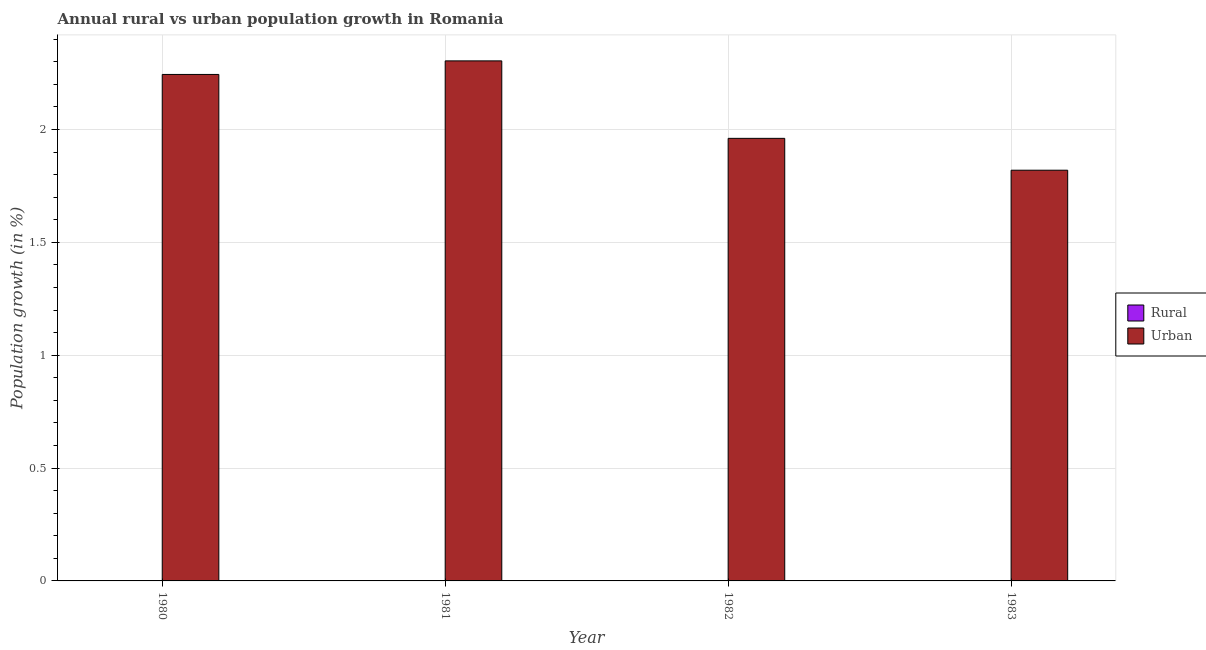Are the number of bars per tick equal to the number of legend labels?
Give a very brief answer. No. Are the number of bars on each tick of the X-axis equal?
Give a very brief answer. Yes. How many bars are there on the 3rd tick from the right?
Your answer should be compact. 1. In how many cases, is the number of bars for a given year not equal to the number of legend labels?
Keep it short and to the point. 4. What is the urban population growth in 1983?
Provide a succinct answer. 1.82. Across all years, what is the maximum urban population growth?
Make the answer very short. 2.3. Across all years, what is the minimum urban population growth?
Your answer should be very brief. 1.82. In which year was the urban population growth maximum?
Provide a short and direct response. 1981. What is the difference between the urban population growth in 1980 and that in 1982?
Your answer should be compact. 0.28. What is the difference between the rural population growth in 1980 and the urban population growth in 1983?
Ensure brevity in your answer.  0. What is the average urban population growth per year?
Your answer should be very brief. 2.08. In the year 1983, what is the difference between the urban population growth and rural population growth?
Your response must be concise. 0. In how many years, is the rural population growth greater than 2 %?
Give a very brief answer. 0. What is the ratio of the urban population growth in 1980 to that in 1983?
Offer a very short reply. 1.23. Is the urban population growth in 1980 less than that in 1983?
Keep it short and to the point. No. What is the difference between the highest and the second highest urban population growth?
Provide a succinct answer. 0.06. What is the difference between the highest and the lowest urban population growth?
Provide a short and direct response. 0.48. How many bars are there?
Keep it short and to the point. 4. Are all the bars in the graph horizontal?
Make the answer very short. No. What is the difference between two consecutive major ticks on the Y-axis?
Give a very brief answer. 0.5. Does the graph contain any zero values?
Your answer should be very brief. Yes. Where does the legend appear in the graph?
Offer a terse response. Center right. How many legend labels are there?
Offer a terse response. 2. What is the title of the graph?
Provide a short and direct response. Annual rural vs urban population growth in Romania. Does "Time to import" appear as one of the legend labels in the graph?
Make the answer very short. No. What is the label or title of the Y-axis?
Provide a succinct answer. Population growth (in %). What is the Population growth (in %) of Rural in 1980?
Provide a short and direct response. 0. What is the Population growth (in %) in Urban  in 1980?
Keep it short and to the point. 2.24. What is the Population growth (in %) of Urban  in 1981?
Give a very brief answer. 2.3. What is the Population growth (in %) of Urban  in 1982?
Your answer should be very brief. 1.96. What is the Population growth (in %) of Rural in 1983?
Your answer should be compact. 0. What is the Population growth (in %) of Urban  in 1983?
Offer a very short reply. 1.82. Across all years, what is the maximum Population growth (in %) of Urban ?
Offer a terse response. 2.3. Across all years, what is the minimum Population growth (in %) of Urban ?
Provide a short and direct response. 1.82. What is the total Population growth (in %) in Urban  in the graph?
Your answer should be compact. 8.33. What is the difference between the Population growth (in %) of Urban  in 1980 and that in 1981?
Keep it short and to the point. -0.06. What is the difference between the Population growth (in %) of Urban  in 1980 and that in 1982?
Your answer should be compact. 0.28. What is the difference between the Population growth (in %) of Urban  in 1980 and that in 1983?
Provide a succinct answer. 0.42. What is the difference between the Population growth (in %) in Urban  in 1981 and that in 1982?
Give a very brief answer. 0.34. What is the difference between the Population growth (in %) of Urban  in 1981 and that in 1983?
Provide a short and direct response. 0.48. What is the difference between the Population growth (in %) in Urban  in 1982 and that in 1983?
Your answer should be compact. 0.14. What is the average Population growth (in %) of Urban  per year?
Your response must be concise. 2.08. What is the ratio of the Population growth (in %) in Urban  in 1980 to that in 1981?
Your answer should be very brief. 0.97. What is the ratio of the Population growth (in %) of Urban  in 1980 to that in 1982?
Ensure brevity in your answer.  1.14. What is the ratio of the Population growth (in %) of Urban  in 1980 to that in 1983?
Offer a very short reply. 1.23. What is the ratio of the Population growth (in %) in Urban  in 1981 to that in 1982?
Your answer should be very brief. 1.18. What is the ratio of the Population growth (in %) of Urban  in 1981 to that in 1983?
Provide a short and direct response. 1.27. What is the ratio of the Population growth (in %) in Urban  in 1982 to that in 1983?
Your answer should be very brief. 1.08. What is the difference between the highest and the second highest Population growth (in %) of Urban ?
Offer a terse response. 0.06. What is the difference between the highest and the lowest Population growth (in %) of Urban ?
Your response must be concise. 0.48. 